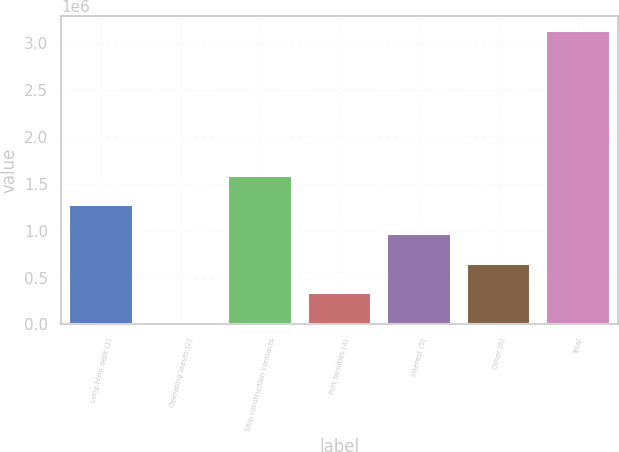<chart> <loc_0><loc_0><loc_500><loc_500><bar_chart><fcel>Long-term debt (1)<fcel>Operating leases (2)<fcel>Ship construction contracts<fcel>Port facilities (4)<fcel>Interest (5)<fcel>Other (6)<fcel>Total<nl><fcel>1.27109e+06<fcel>28973<fcel>1.58162e+06<fcel>339502<fcel>960558<fcel>650030<fcel>3.13426e+06<nl></chart> 